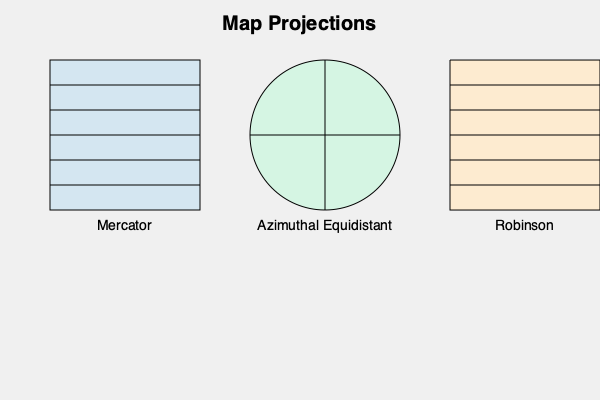Which map projection would be most suitable for analyzing cross-border activities, particularly when investigating potential violations of regulations that involve accurate distance measurements between different countries? To determine the most suitable map projection for analyzing cross-border activities, especially when investigating potential violations of regulations involving accurate distance measurements, we need to consider the properties of different map projections:

1. Mercator Projection:
   - Preserves angles and shapes for small areas
   - Significantly distorts area and distance, especially near the poles
   - Not suitable for accurate distance measurements across large areas

2. Robinson Projection:
   - Compromise projection that reduces distortion in both area and shape
   - Does not preserve distances accurately
   - Better for general visual representation but not ideal for precise measurements

3. Azimuthal Equidistant Projection:
   - Preserves distances and directions from the center point to all other points on the map
   - Distances between other points may be distorted
   - Ideal for measuring distances from a central location to any other point

For cross-border investigations requiring accurate distance measurements:

1. The Azimuthal Equidistant projection is the most suitable choice.
2. It allows for precise distance calculations from a central point (e.g., the investigator's location or a point of interest) to any other location on the map.
3. This projection is particularly useful when investigating activities that span multiple countries or regions, as it maintains distance accuracy from the center.
4. It can help in determining jurisdictional boundaries and assessing the scope of cross-border violations based on distance.
5. The projection's ability to preserve directions is also beneficial for analyzing movement patterns or trade routes involved in potential regulatory violations.

While the other projections have their uses, they do not provide the same level of accuracy for distance measurements in cross-border investigations.
Answer: Azimuthal Equidistant projection 